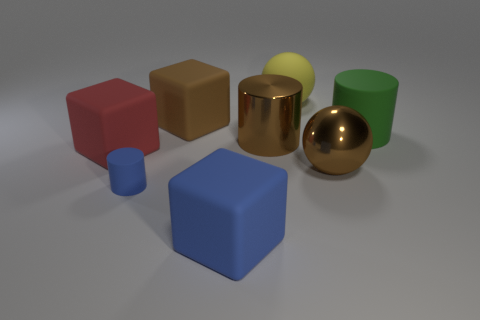How many other objects are there of the same color as the tiny thing?
Offer a terse response. 1. Do the big ball in front of the big brown cylinder and the metal cylinder have the same color?
Offer a terse response. Yes. What size is the block that is the same color as the tiny cylinder?
Your answer should be very brief. Large. The large blue rubber object is what shape?
Ensure brevity in your answer.  Cube. How many small purple cylinders have the same material as the small blue cylinder?
Ensure brevity in your answer.  0. Does the metallic cylinder have the same color as the rubber cube that is behind the large red matte cube?
Offer a terse response. Yes. How many blue cylinders are there?
Provide a short and direct response. 1. Are there any other things that have the same color as the small rubber object?
Offer a very short reply. Yes. What is the color of the cube that is left of the cube behind the big cylinder that is to the right of the brown metallic sphere?
Your response must be concise. Red. Are the big red cube and the big cylinder that is right of the metallic cylinder made of the same material?
Ensure brevity in your answer.  Yes. 